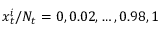<formula> <loc_0><loc_0><loc_500><loc_500>x _ { t } ^ { i } / N _ { t } = 0 , 0 . 0 2 , \dots , 0 . 9 8 , 1</formula> 